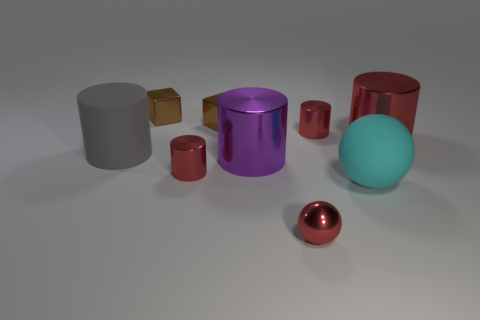The large red thing is what shape?
Ensure brevity in your answer.  Cylinder. Are there fewer metallic spheres on the left side of the large purple thing than small red metallic cylinders?
Keep it short and to the point. Yes. Is there a big cyan rubber thing of the same shape as the big purple thing?
Offer a terse response. No. There is a cyan matte object that is the same size as the purple metallic cylinder; what is its shape?
Give a very brief answer. Sphere. What number of things are tiny green shiny cubes or big purple objects?
Offer a terse response. 1. Are any green metallic cubes visible?
Provide a short and direct response. No. Are there fewer blue metal balls than cylinders?
Offer a very short reply. Yes. Is there a cylinder of the same size as the red ball?
Offer a very short reply. Yes. Do the large cyan rubber thing and the small red metal object that is behind the large red object have the same shape?
Make the answer very short. No. How many cylinders are small red objects or matte objects?
Provide a succinct answer. 3. 